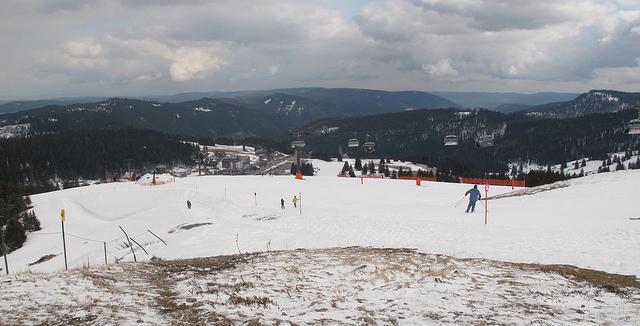Where is this location?
Quick response, please. Ski resort. What color is the snow?
Concise answer only. White. What kind of landscape is in this picture?
Be succinct. Mountains. What activity is the man in blue doing?
Give a very brief answer. Skiing. How many people are in the picture?
Answer briefly. 4. Why are the mountains covered with snow?
Concise answer only. Winter. Are these mountains located in California?
Write a very short answer. No. 